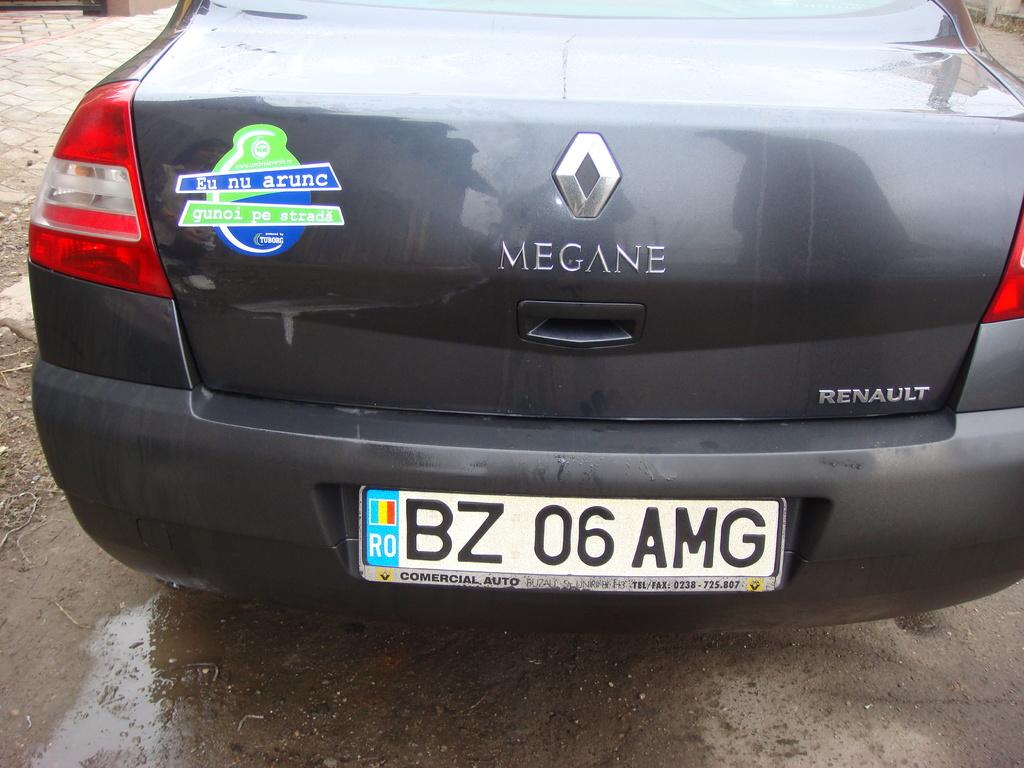<image>
Share a concise interpretation of the image provided. The back end of a dark grey Renault car has a green and blue sticker on it. 